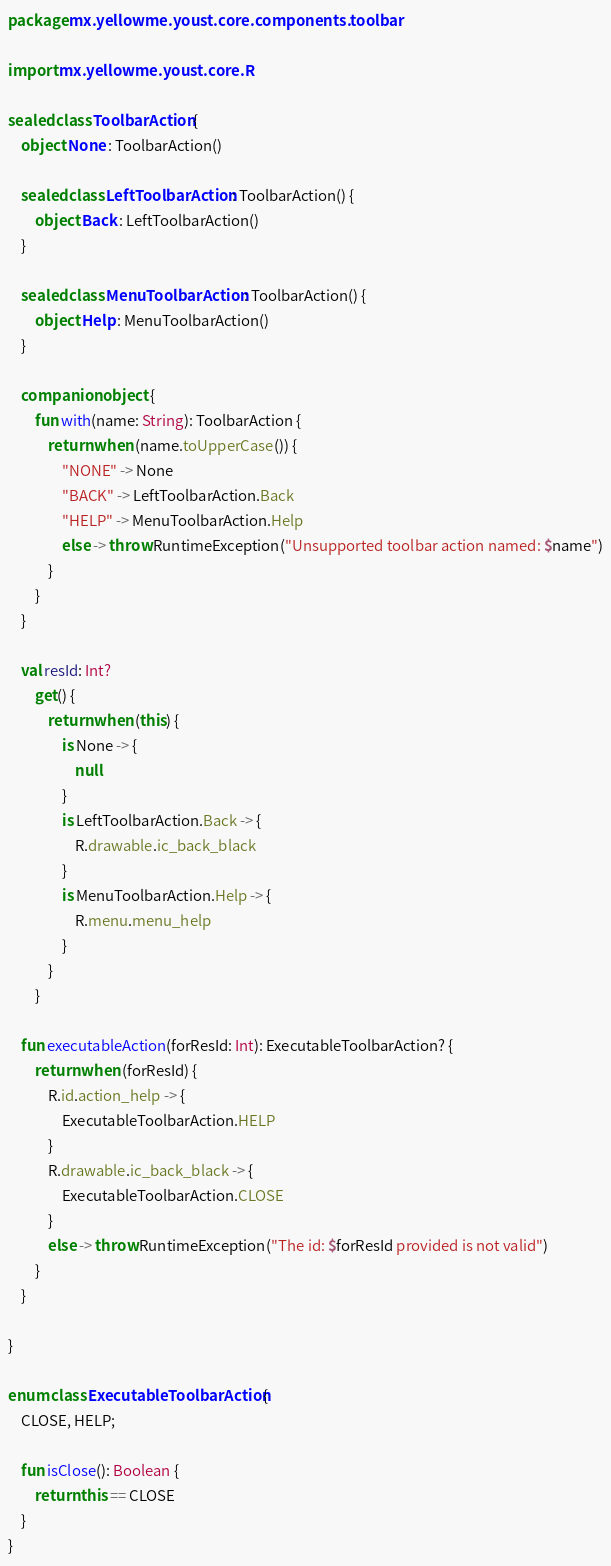Convert code to text. <code><loc_0><loc_0><loc_500><loc_500><_Kotlin_>package mx.yellowme.youst.core.components.toolbar

import mx.yellowme.youst.core.R

sealed class ToolbarAction {
    object None : ToolbarAction()

    sealed class LeftToolbarAction : ToolbarAction() {
        object Back : LeftToolbarAction()
    }

    sealed class MenuToolbarAction : ToolbarAction() {
        object Help : MenuToolbarAction()
    }

    companion object {
        fun with(name: String): ToolbarAction {
            return when (name.toUpperCase()) {
                "NONE" -> None
                "BACK" -> LeftToolbarAction.Back
                "HELP" -> MenuToolbarAction.Help
                else -> throw RuntimeException("Unsupported toolbar action named: $name")
            }
        }
    }

    val resId: Int?
        get() {
            return when (this) {
                is None -> {
                    null
                }
                is LeftToolbarAction.Back -> {
                    R.drawable.ic_back_black
                }
                is MenuToolbarAction.Help -> {
                    R.menu.menu_help
                }
            }
        }

    fun executableAction(forResId: Int): ExecutableToolbarAction? {
        return when (forResId) {
            R.id.action_help -> {
                ExecutableToolbarAction.HELP
            }
            R.drawable.ic_back_black -> {
                ExecutableToolbarAction.CLOSE
            }
            else -> throw RuntimeException("The id: $forResId provided is not valid")
        }
    }

}

enum class ExecutableToolbarAction {
    CLOSE, HELP;

    fun isClose(): Boolean {
        return this == CLOSE
    }
}
</code> 